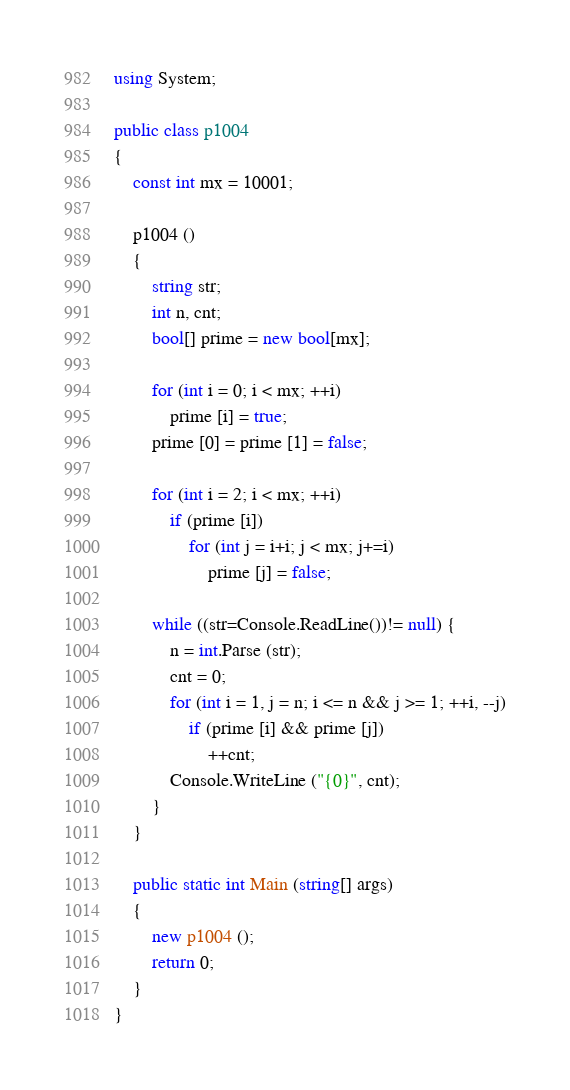<code> <loc_0><loc_0><loc_500><loc_500><_C#_>using System;

public class p1004
{
	const int mx = 10001;
	
	p1004 ()
	{
		string str;
		int n, cnt;
		bool[] prime = new bool[mx];
		
		for (int i = 0; i < mx; ++i)
			prime [i] = true;
		prime [0] = prime [1] = false;
		
		for (int i = 2; i < mx; ++i)
			if (prime [i])
				for (int j = i+i; j < mx; j+=i)
					prime [j] = false;
		
		while ((str=Console.ReadLine())!= null) {
			n = int.Parse (str);
			cnt = 0;
			for (int i = 1, j = n; i <= n && j >= 1; ++i, --j)
				if (prime [i] && prime [j])
					++cnt;
			Console.WriteLine ("{0}", cnt);
		}
	}
	
	public static int Main (string[] args)
	{
		new p1004 ();
		return 0;
	}
}</code> 